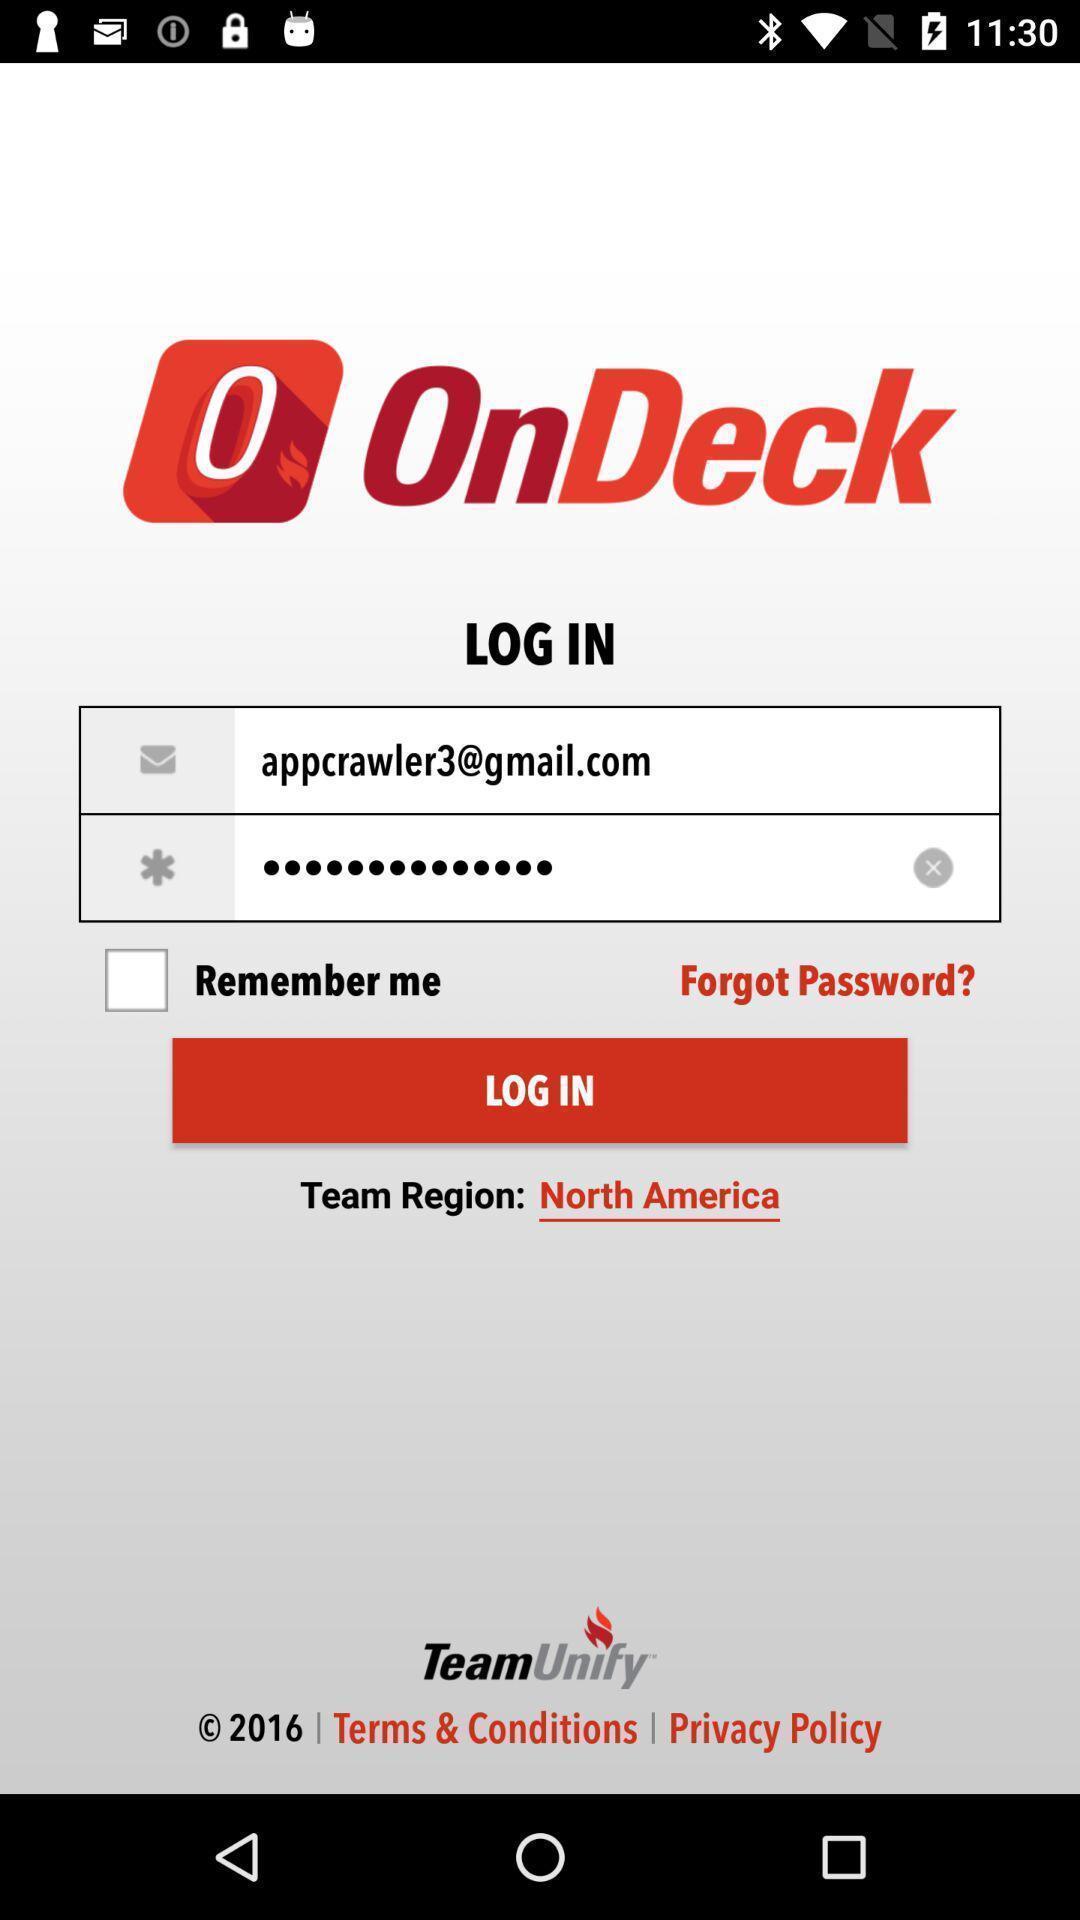Give me a summary of this screen capture. Login page for the team management application. 